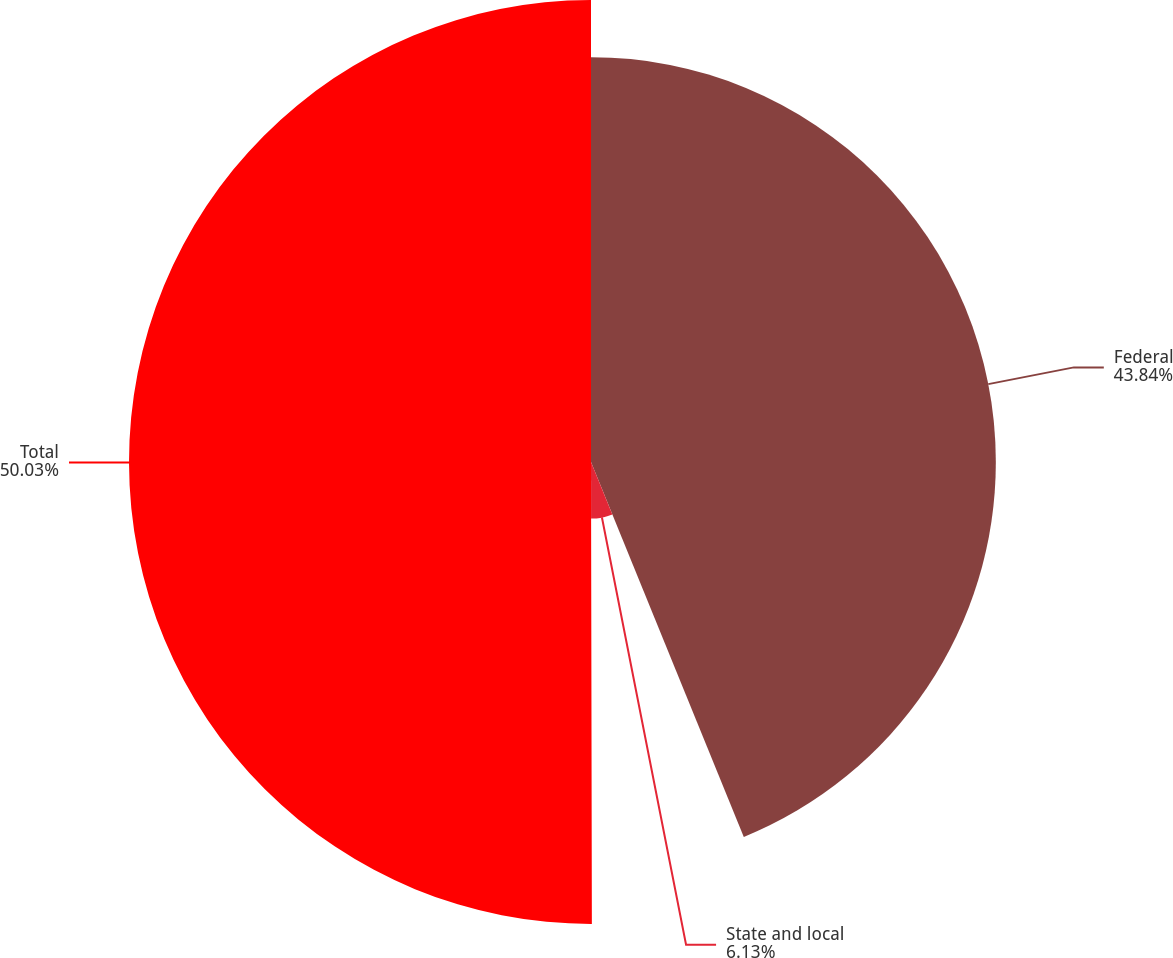<chart> <loc_0><loc_0><loc_500><loc_500><pie_chart><fcel>Federal<fcel>State and local<fcel>Total<nl><fcel>43.84%<fcel>6.13%<fcel>50.03%<nl></chart> 